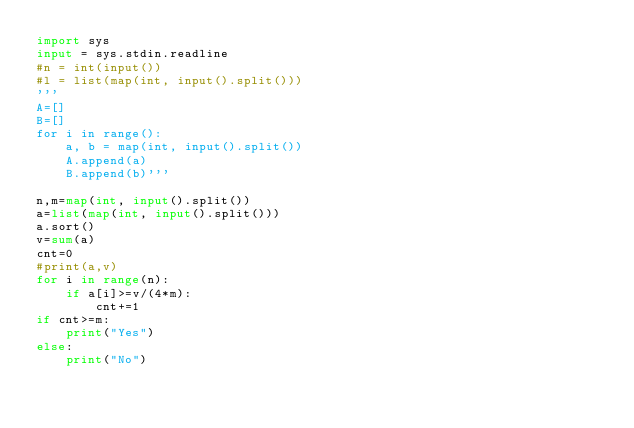<code> <loc_0><loc_0><loc_500><loc_500><_Python_>import sys
input = sys.stdin.readline
#n = int(input())
#l = list(map(int, input().split()))
'''
A=[]
B=[]
for i in range():
    a, b = map(int, input().split())
    A.append(a)
    B.append(b)'''

n,m=map(int, input().split())
a=list(map(int, input().split()))
a.sort()
v=sum(a)
cnt=0
#print(a,v)
for i in range(n):
    if a[i]>=v/(4*m):
        cnt+=1
if cnt>=m:
    print("Yes")
else:
    print("No")</code> 